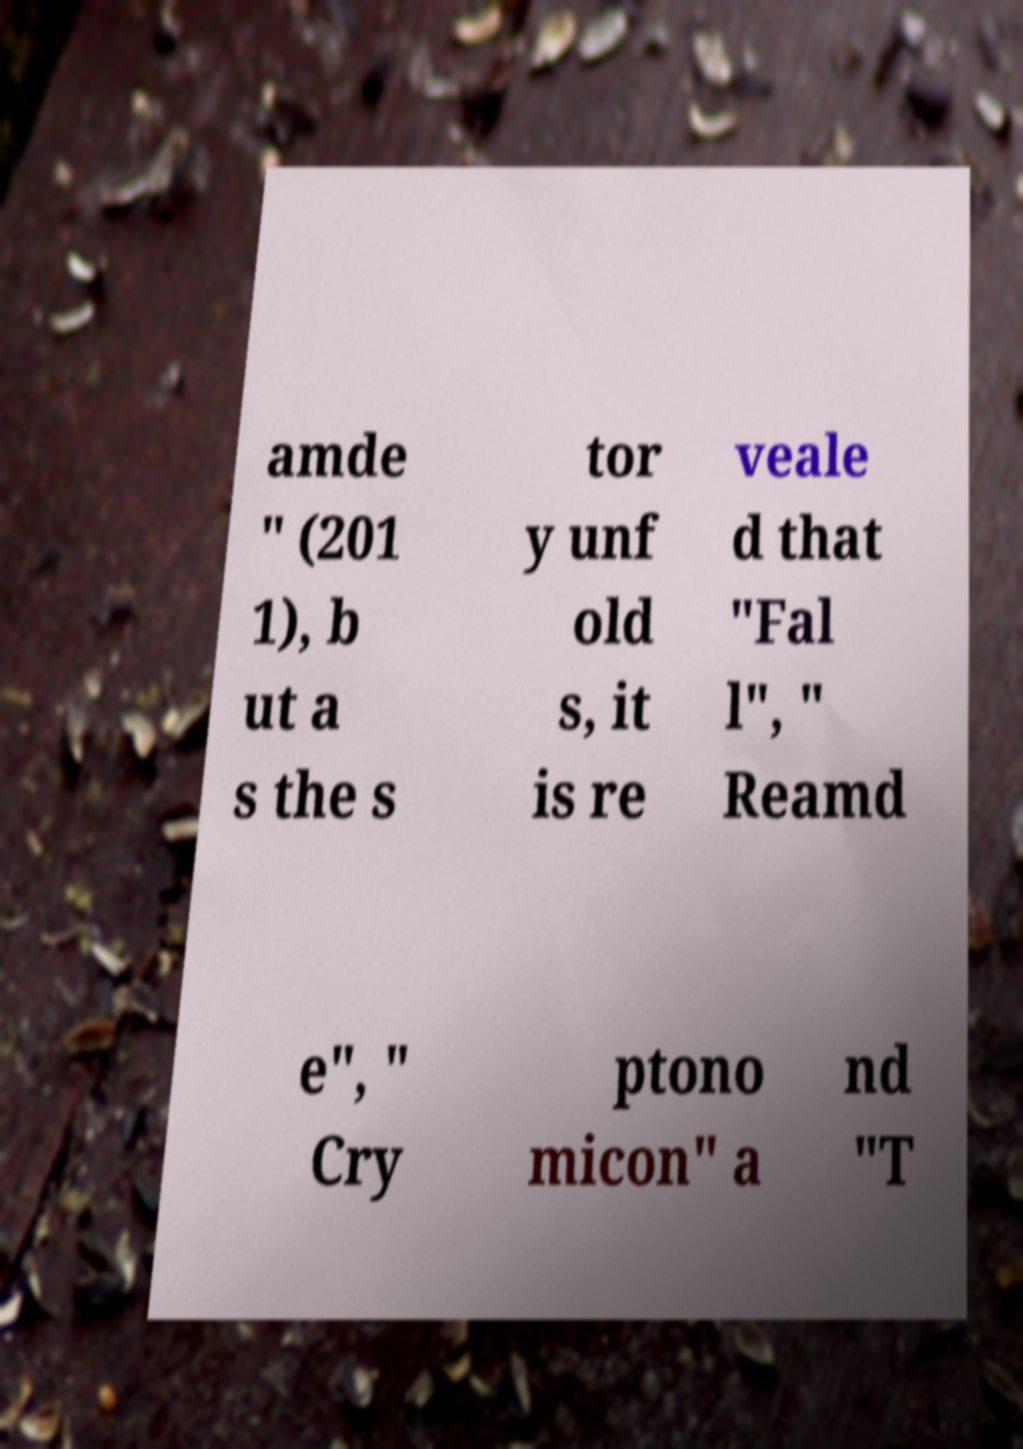Can you read and provide the text displayed in the image?This photo seems to have some interesting text. Can you extract and type it out for me? amde " (201 1), b ut a s the s tor y unf old s, it is re veale d that "Fal l", " Reamd e", " Cry ptono micon" a nd "T 